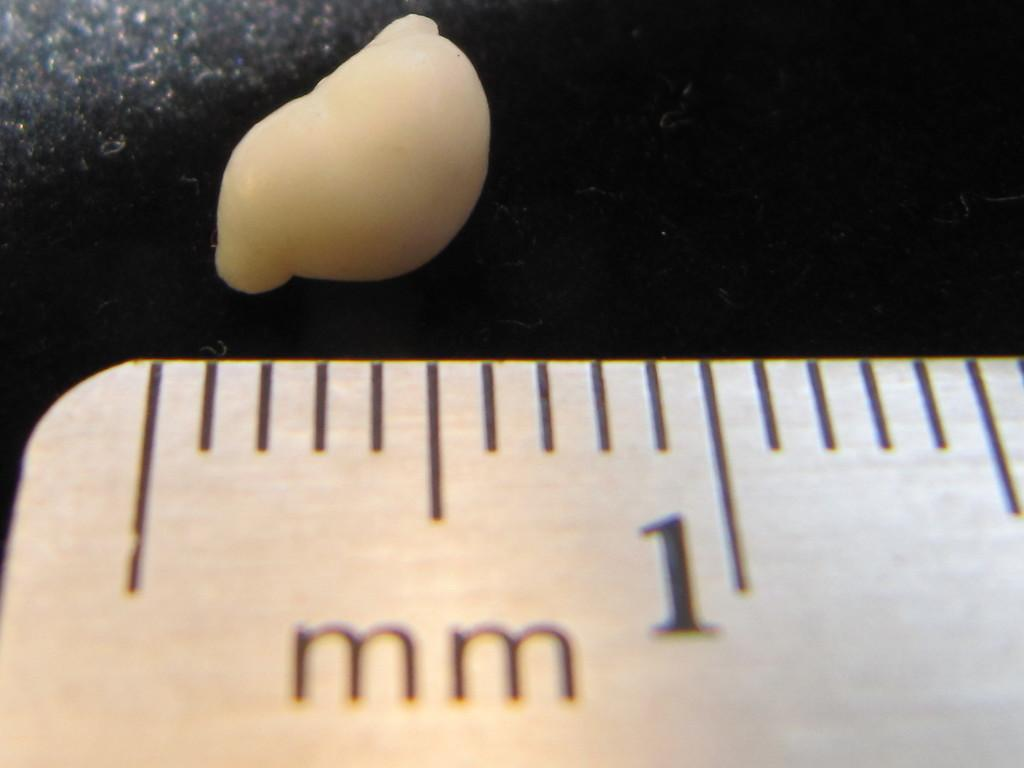<image>
Create a compact narrative representing the image presented. A ruler placed on the counter with the 1 mm shown 